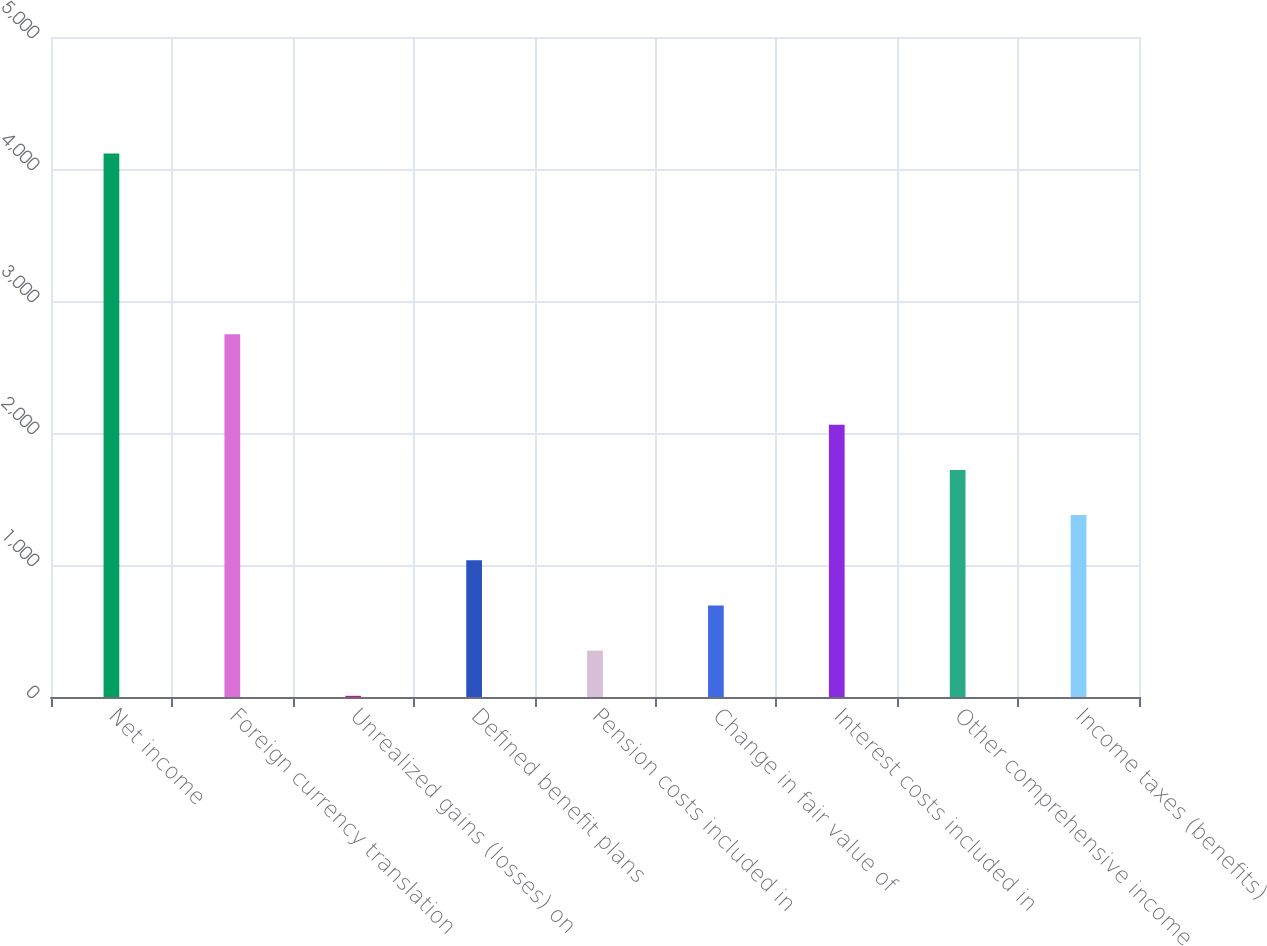<chart> <loc_0><loc_0><loc_500><loc_500><bar_chart><fcel>Net income<fcel>Foreign currency translation<fcel>Unrealized gains (losses) on<fcel>Defined benefit plans<fcel>Pension costs included in<fcel>Change in fair value of<fcel>Interest costs included in<fcel>Other comprehensive income<fcel>Income taxes (benefits)<nl><fcel>4116.6<fcel>2747.4<fcel>9<fcel>1035.9<fcel>351.3<fcel>693.6<fcel>2062.8<fcel>1720.5<fcel>1378.2<nl></chart> 